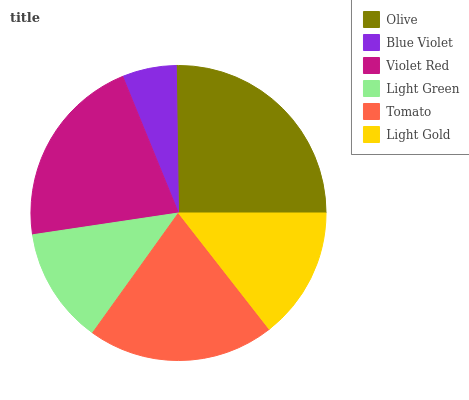Is Blue Violet the minimum?
Answer yes or no. Yes. Is Olive the maximum?
Answer yes or no. Yes. Is Violet Red the minimum?
Answer yes or no. No. Is Violet Red the maximum?
Answer yes or no. No. Is Violet Red greater than Blue Violet?
Answer yes or no. Yes. Is Blue Violet less than Violet Red?
Answer yes or no. Yes. Is Blue Violet greater than Violet Red?
Answer yes or no. No. Is Violet Red less than Blue Violet?
Answer yes or no. No. Is Tomato the high median?
Answer yes or no. Yes. Is Light Gold the low median?
Answer yes or no. Yes. Is Violet Red the high median?
Answer yes or no. No. Is Tomato the low median?
Answer yes or no. No. 